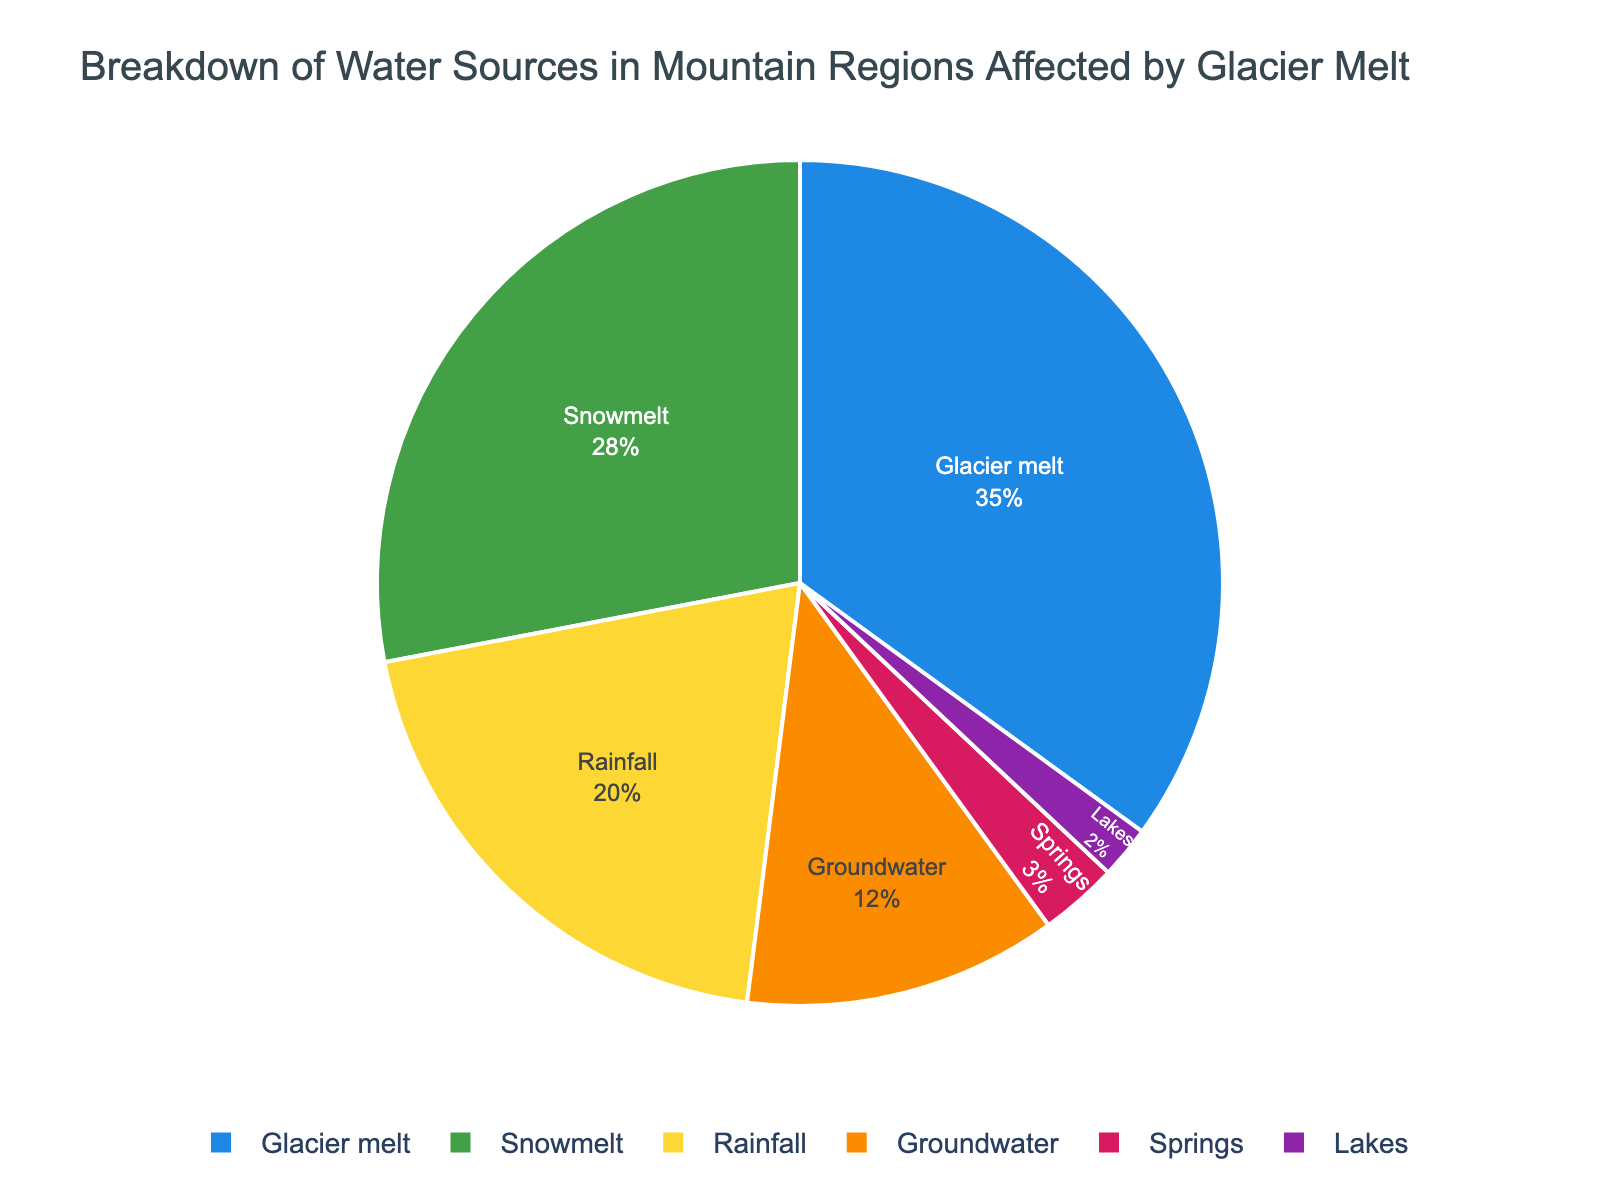What is the largest water source in mountain regions affected by glacier melt? The pie chart shows different water sources and their corresponding percentages. The largest segment corresponds to 'Glacier melt' at 35%.
Answer: Glacier melt Which water source contributes more, groundwater or lakes? The chart indicates that groundwater contributes 12% while lakes contribute 2%. 12% is greater than 2%.
Answer: Groundwater What is the combined percentage of rainfall and snowmelt? According to the pie chart, rainfall contributes 20% and snowmelt contributes 28%. Adding these together gives 20% + 28% = 48%.
Answer: 48% Is the contribution of springs more or less than 5%? The segment for springs on the pie chart shows a percentage of 3%, which is less than 5%.
Answer: Less Which two sources combined are almost equal to the percentage of glacier melt? The chart shows 'Snowmelt' at 28% and 'Rainfall' at 20%. The combined percentage of these two is 48%, which is close to 'Glacier melt' at 35%. However, the sum of snowmelt and rainfall exceeds the percentage of glacier melt. Thus, we need to consider groundwater (12%) and rainfall (20%), as these combined give 32%, which is closest to glacier melt percentage.
Answer: Groundwater and Rainfall How much larger is the contribution of glacier melt compared to the contribution of rainfall? Glacier melt contributes 35% while rainfall contributes 20%. The difference is 35% - 20% = 15%.
Answer: 15% What fraction of the total water sources is provided by lakes and springs combined? Lakes contribute 2% and springs contribute 3%. The combined contribution is 2% + 3% = 5%. Converting this to a fraction of the total 100%, we get 5/100 = 1/20.
Answer: 1/20 Which source has the smallest contribution and what percentage does it represent? From the pie chart, lakes have the smallest contribution with a percentage of 2%.
Answer: Lakes, 2% If the groundwater percentage were doubled, how would it compare to the glacier melt percentage? The current groundwater percentage is 12%. If it were doubled, it would be 12% * 2 = 24%. This is still less than the glacier melt percentage of 35%.
Answer: Less 